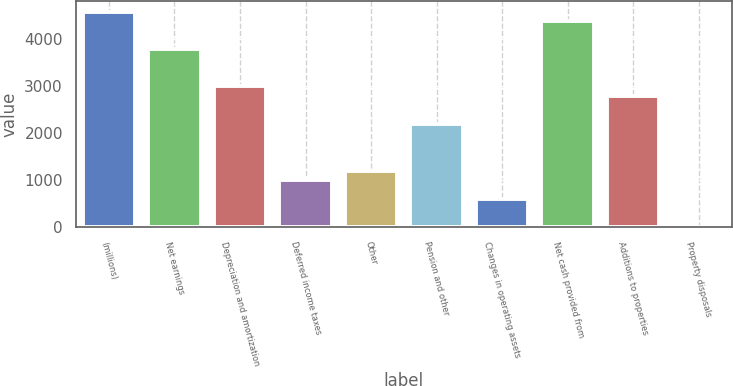<chart> <loc_0><loc_0><loc_500><loc_500><bar_chart><fcel>(millions)<fcel>Net earnings<fcel>Depreciation and amortization<fcel>Deferred income taxes<fcel>Other<fcel>Pension and other<fcel>Changes in operating assets<fcel>Net cash provided from<fcel>Additions to properties<fcel>Property disposals<nl><fcel>4588.96<fcel>3793.28<fcel>2997.6<fcel>1008.4<fcel>1207.32<fcel>2201.92<fcel>610.56<fcel>4390.04<fcel>2798.68<fcel>13.8<nl></chart> 